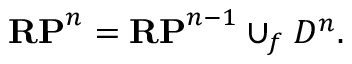<formula> <loc_0><loc_0><loc_500><loc_500>R P ^ { n } = R P ^ { n - 1 } \cup _ { f } D ^ { n } .</formula> 